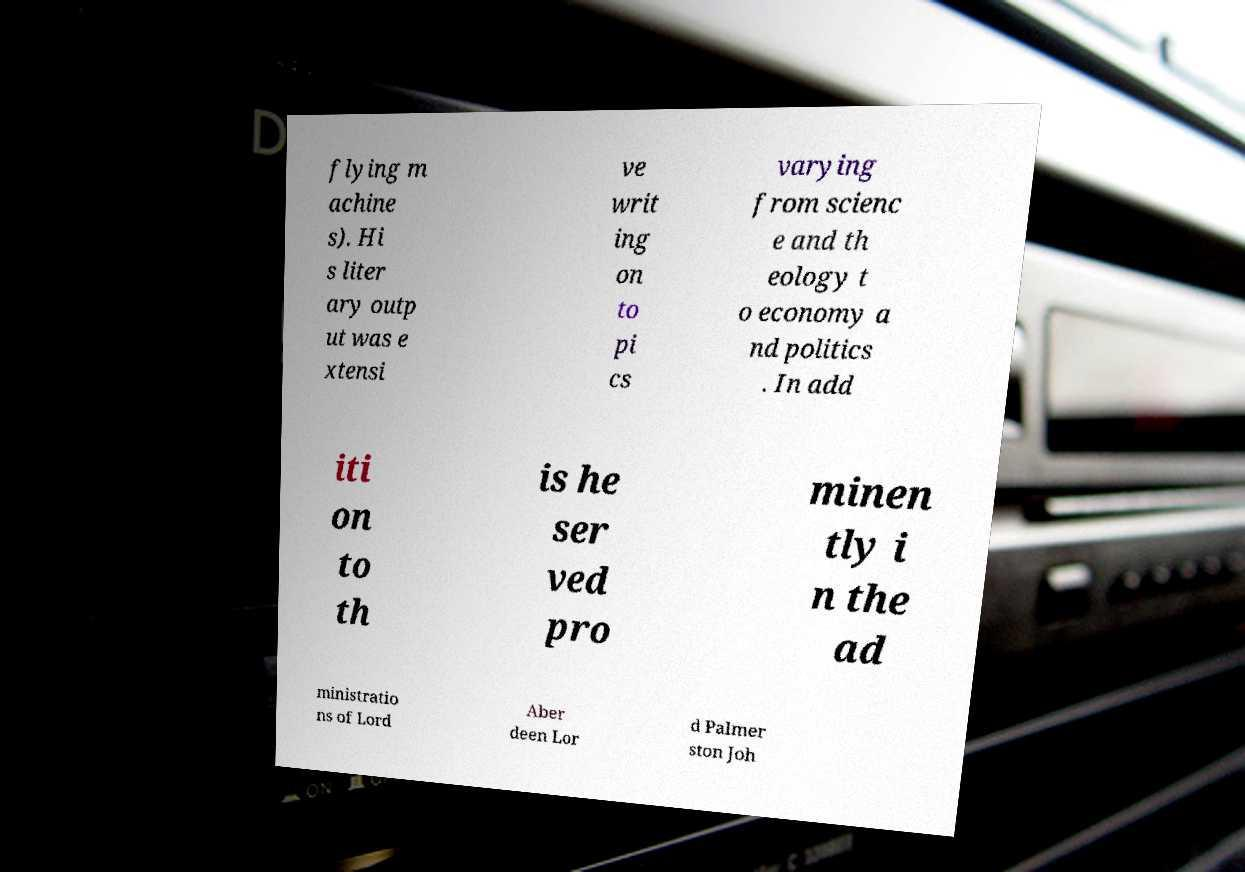Please identify and transcribe the text found in this image. flying m achine s). Hi s liter ary outp ut was e xtensi ve writ ing on to pi cs varying from scienc e and th eology t o economy a nd politics . In add iti on to th is he ser ved pro minen tly i n the ad ministratio ns of Lord Aber deen Lor d Palmer ston Joh 